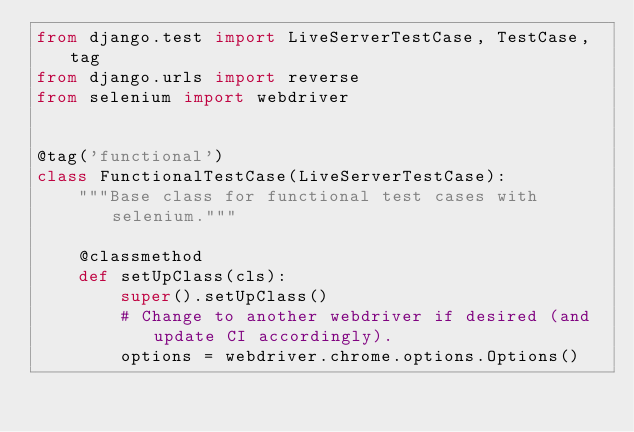<code> <loc_0><loc_0><loc_500><loc_500><_Python_>from django.test import LiveServerTestCase, TestCase, tag
from django.urls import reverse
from selenium import webdriver


@tag('functional')
class FunctionalTestCase(LiveServerTestCase):
    """Base class for functional test cases with selenium."""

    @classmethod
    def setUpClass(cls):
        super().setUpClass()
        # Change to another webdriver if desired (and update CI accordingly).
        options = webdriver.chrome.options.Options()</code> 